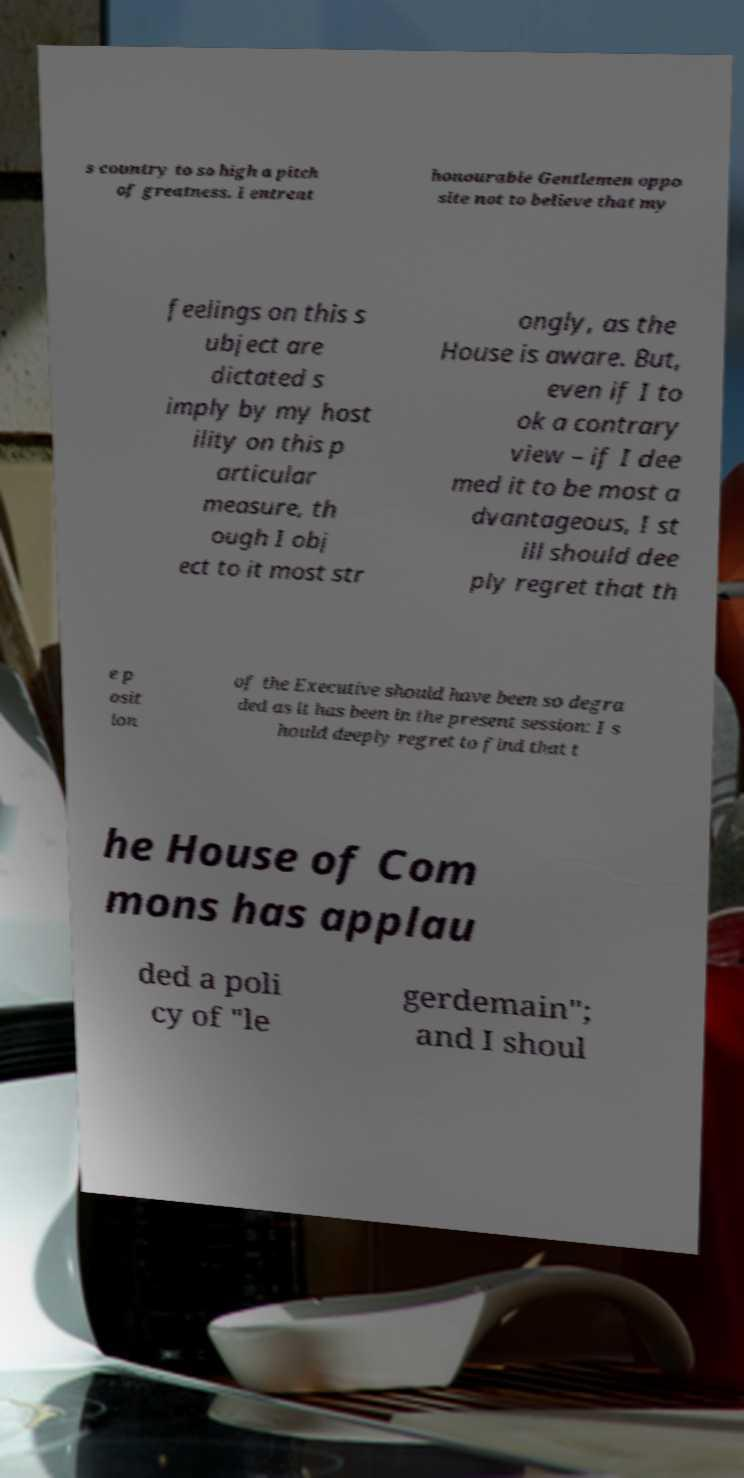Please read and relay the text visible in this image. What does it say? s country to so high a pitch of greatness. I entreat honourable Gentlemen oppo site not to believe that my feelings on this s ubject are dictated s imply by my host ility on this p articular measure, th ough I obj ect to it most str ongly, as the House is aware. But, even if I to ok a contrary view – if I dee med it to be most a dvantageous, I st ill should dee ply regret that th e p osit ion of the Executive should have been so degra ded as it has been in the present session: I s hould deeply regret to find that t he House of Com mons has applau ded a poli cy of "le gerdemain"; and I shoul 